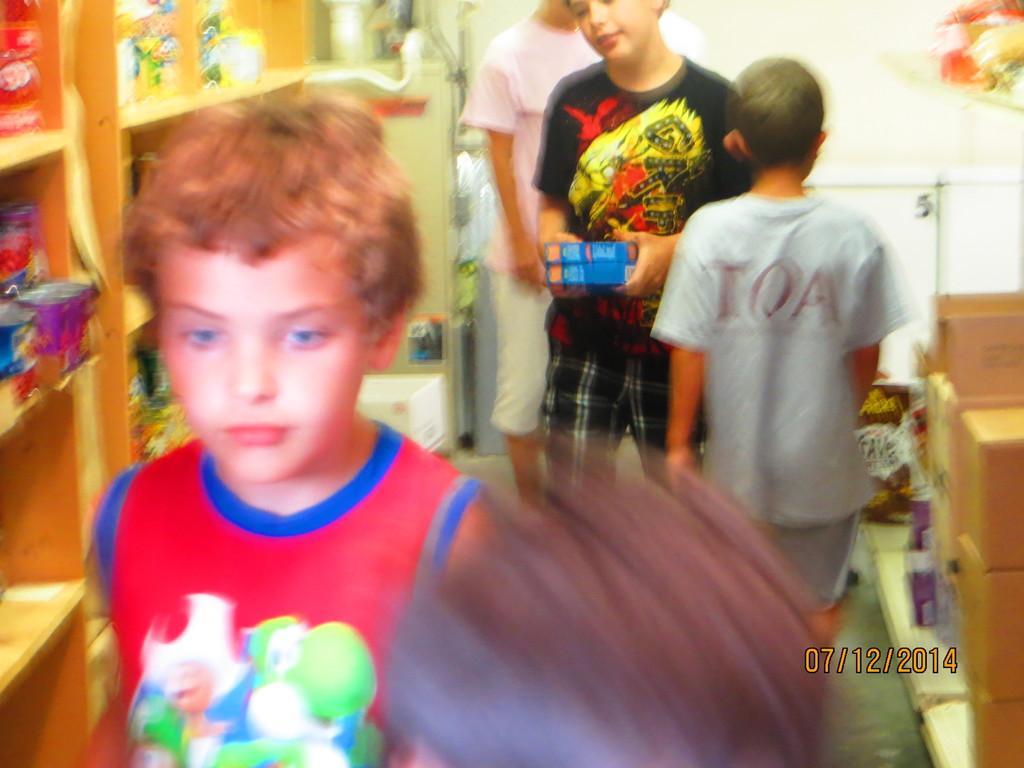Please provide a concise description of this image. In this picture there is a boy who is wearing red t-shirt. He is standing near to the shelf. On the shelf i can see some object. On the right there is a boy who is standing near to the wooden table, beside him there is another boy who is holding the books. Behind him there is a boy who is wearing a pink t-shirt. He is standing near to the wall and fridge. In the top right corner there are fruits on the rack. In the bottom right corner there is a watermark. 